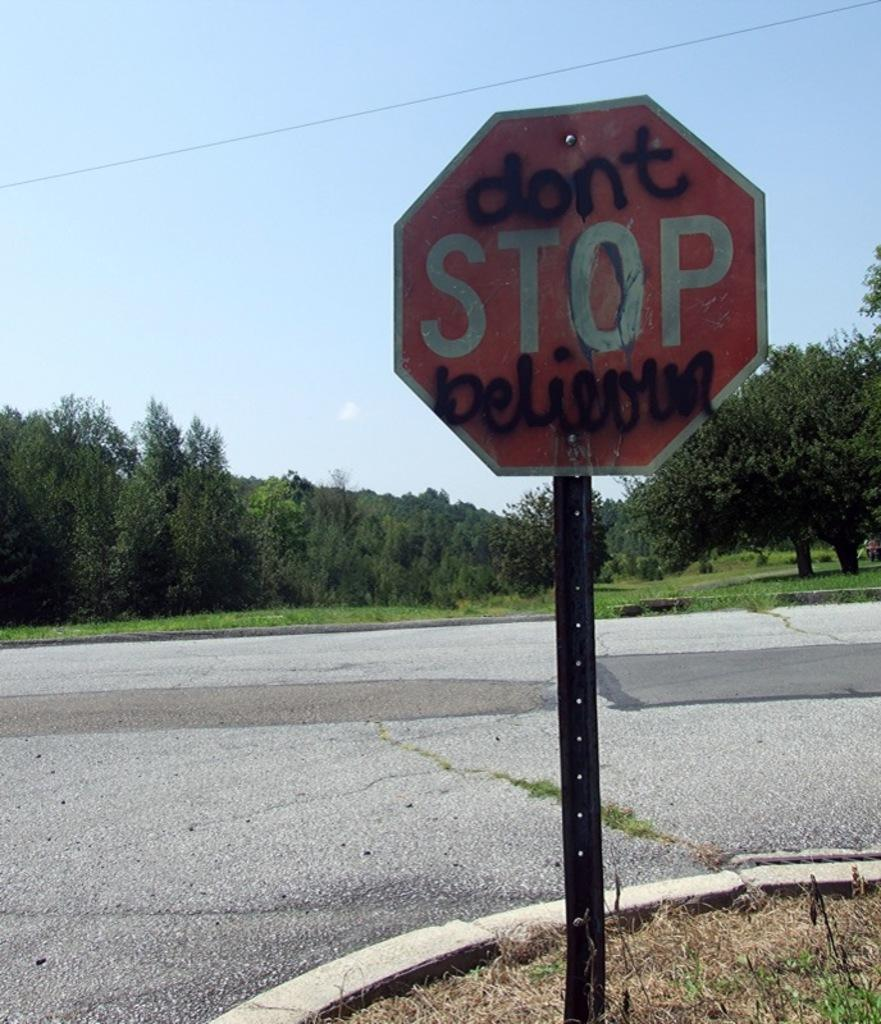<image>
Offer a succinct explanation of the picture presented. the word stop is on the red sign that is outside 